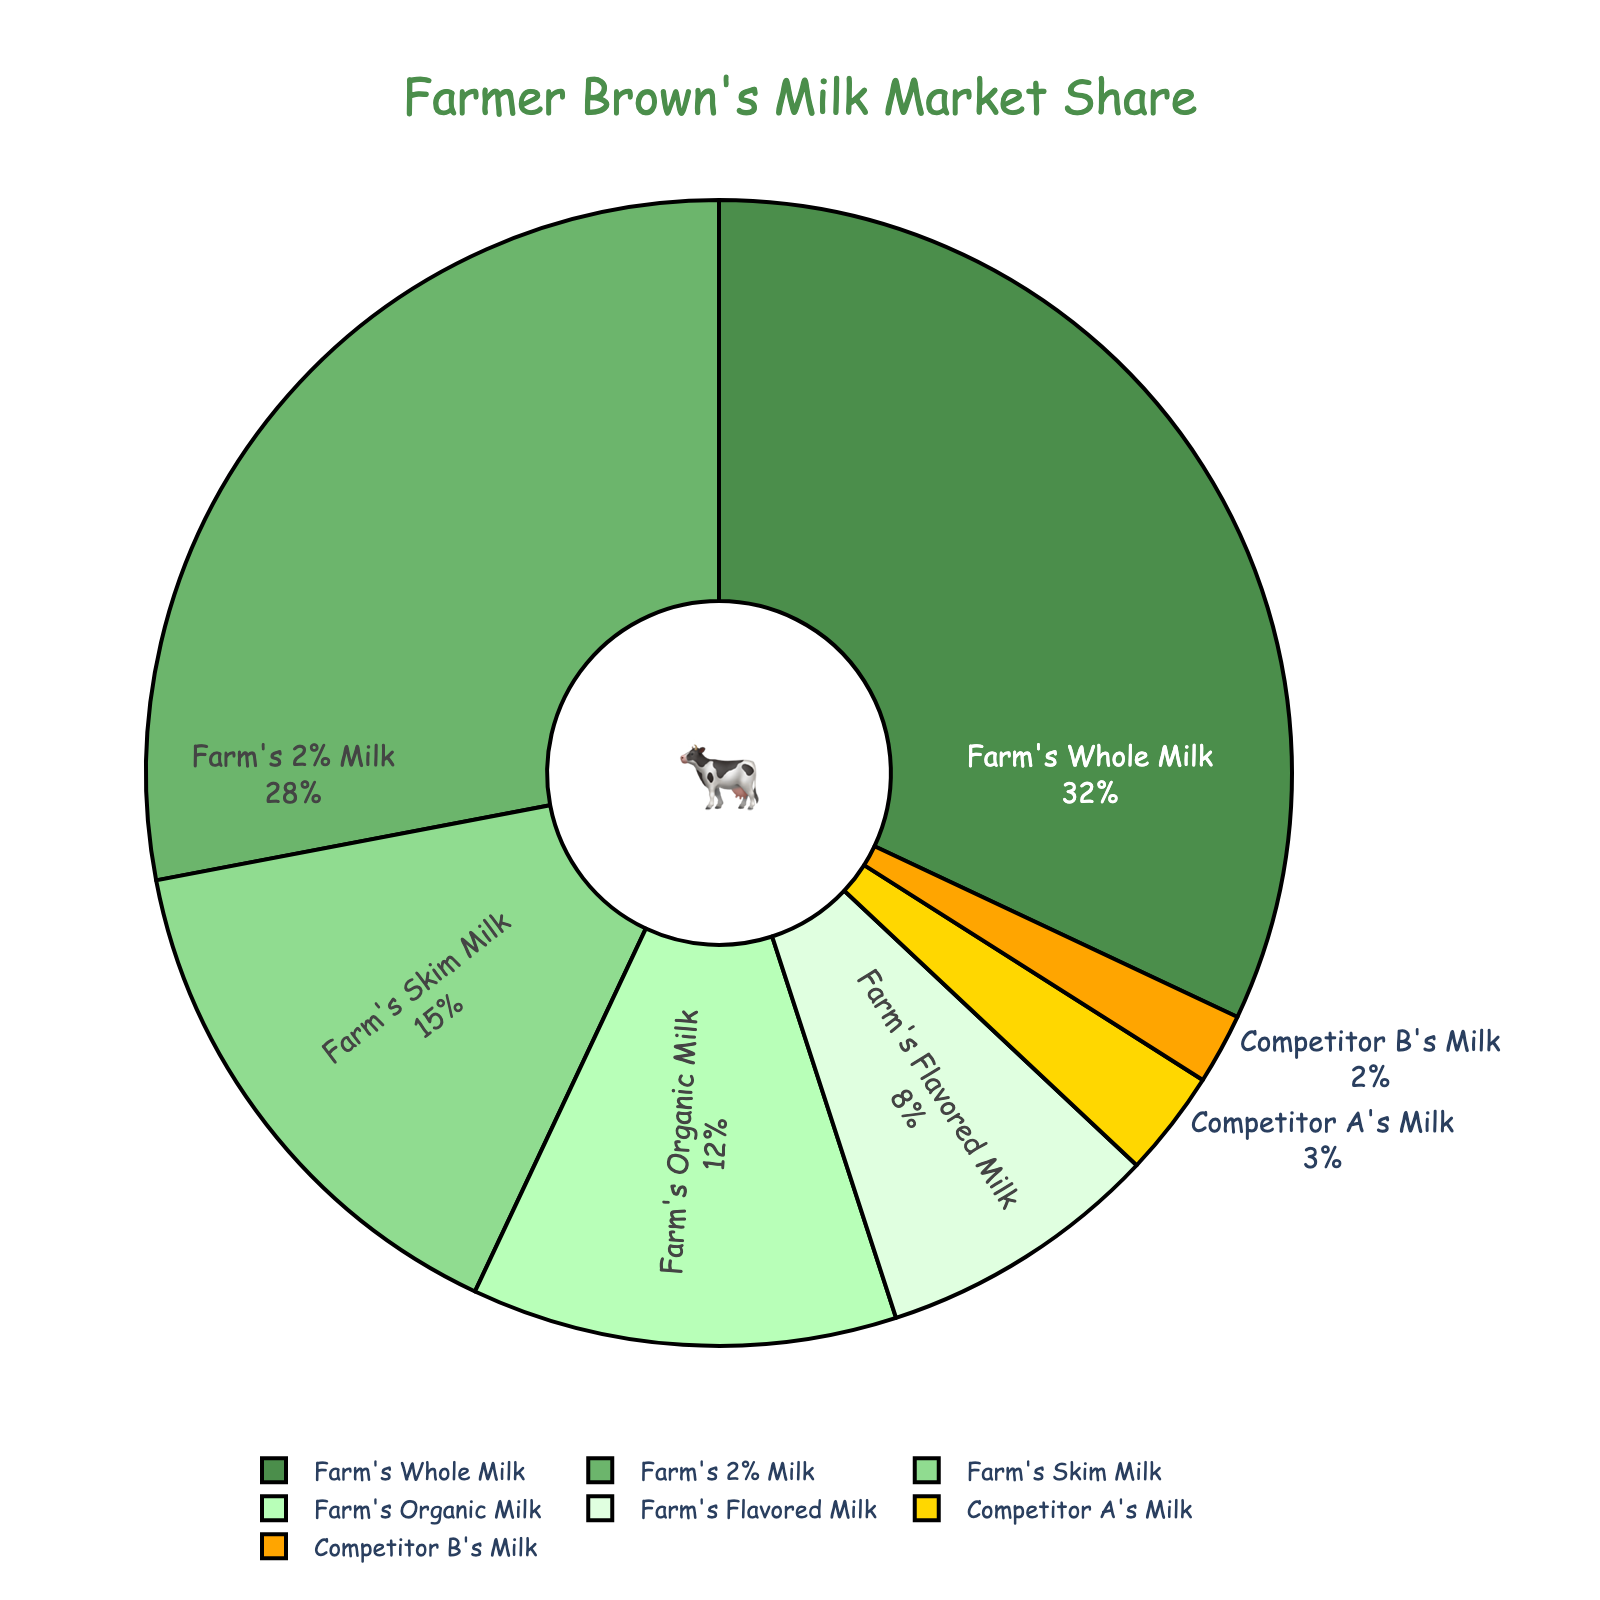What's the market share of Farm's Whole Milk? The pie chart clearly shows that Farm's Whole Milk has a 32% market share.
Answer: 32% Which product has the smallest market share? By examining the pie chart, we see that Competitor B's Milk holds the smallest market share at 2%.
Answer: Competitor B's Milk Is the market share of Farm's 2% Milk larger than the combined share of Competitor A's and Competitor B's Milk? Farm's 2% Milk has a market share of 28%. The combined market share of Competitor A's Milk (3%) and Competitor B's Milk (2%) is 5%. Therefore, 28% is larger than 5%.
Answer: Yes What percentage of the market is held by all Farm-branded milk products combined? Adding up the shares for Farm's Whole Milk (32%), Farm's 2% Milk (28%), Farm's Skim Milk (15%), Farm's Organic Milk (12%), and Farm's Flavored Milk (8%) gives us 95%.
Answer: 95% Which product category has a larger market share: Farm's Skim Milk or Farm's Organic Milk? The pie chart indicates that Farm's Skim Milk has a 15% market share, while Farm's Organic Milk has a 12% market share. Therefore, Farm's Skim Milk has a larger market share.
Answer: Farm's Skim Milk How does the market share of Farm's Flavored Milk compare to that of Competitor A's Milk? Farm's Flavored Milk has a market share of 8%, while Competitor A's Milk has 3%. Hence, Farm's Flavored Milk has a higher market share.
Answer: Farm's Flavored Milk What is the total market share for the competitors' milk products? The combined market share for Competitor A's Milk (3%) and Competitor B's Milk (2%) is 5%.
Answer: 5% How much more market share does the leading product have compared to the second-leading product? Farm's Whole Milk leads with 32%, and Farm's 2% Milk follows with 28%. The difference between them is 32% - 28% = 4%.
Answer: 4% What is the average market share of all Farm-branded milk products? To find the average market share of Farm-branded products, sum their shares: 32% + 28% + 15% + 12% + 8% = 95%. Then divide by the number of products (5): 95% / 5 = 19%.
Answer: 19% What fraction of the market share is occupied by the farm’s products compared to the competitors' products? The farm's products occupy 95% of the market, while the competitors occupy 5%. This creates a ratio of 95% to 5% or 19 to 1.
Answer: 19 to 1 